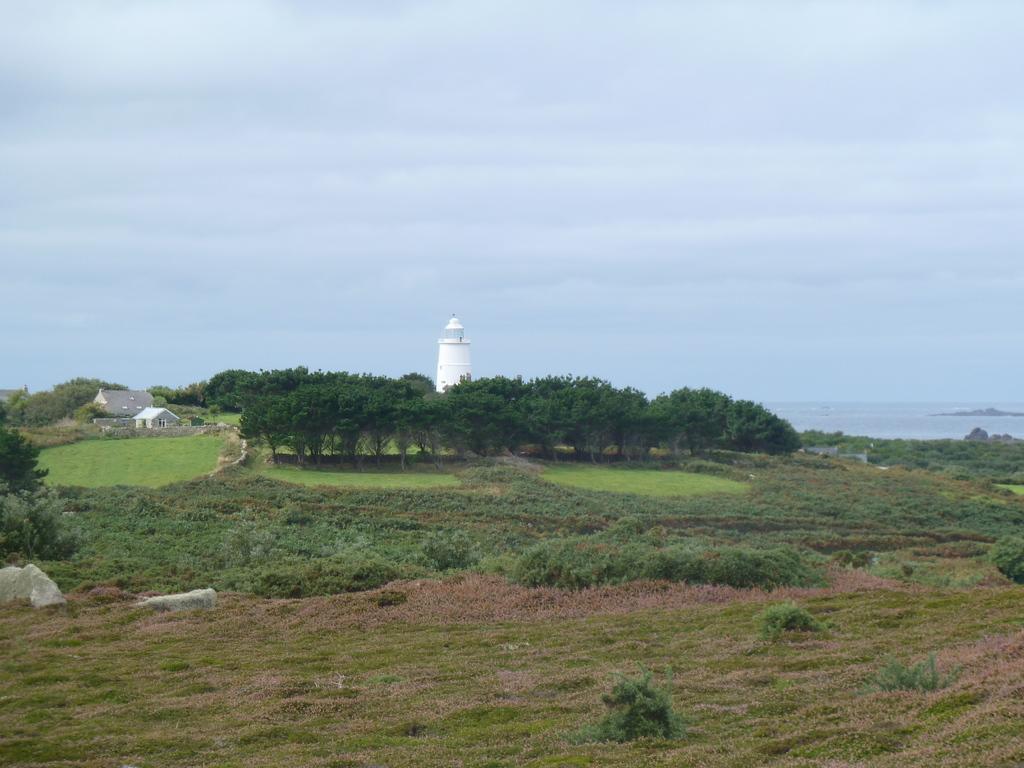Can you describe this image briefly? In the background we can see the sky, tower and houses. In this picture we can see the trees, plants, rocks and grass. 